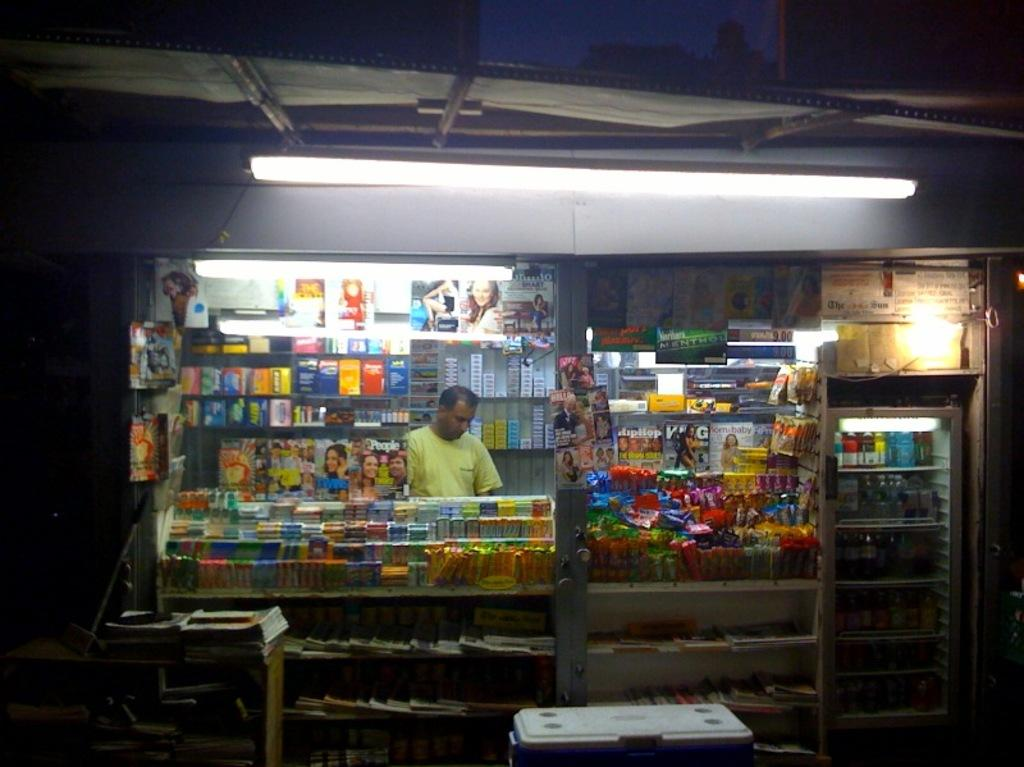Where is the person located in the image? The person is inside a shop. What can be found in the shop? The shop is selling various kinds of objects. What type of lighting is present in the image? There is a tube light on the top of the image. What type of tub is visible in the image? There is no tub present in the image. How does the person use the comb in the image? There is no comb present in the image. 